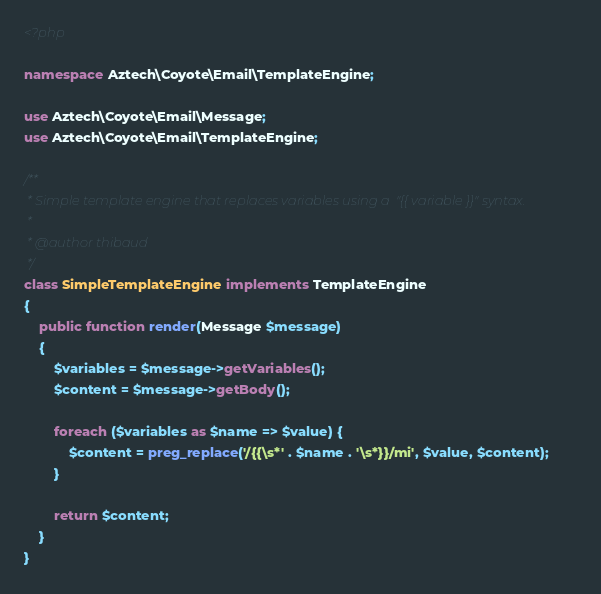Convert code to text. <code><loc_0><loc_0><loc_500><loc_500><_PHP_><?php

namespace Aztech\Coyote\Email\TemplateEngine;

use Aztech\Coyote\Email\Message;
use Aztech\Coyote\Email\TemplateEngine;

/**
 * Simple template engine that replaces variables using a  "{{ variable }}" syntax.
 *
 * @author thibaud
 */
class SimpleTemplateEngine implements TemplateEngine
{
    public function render(Message $message)
    {
        $variables = $message->getVariables();
        $content = $message->getBody();

        foreach ($variables as $name => $value) {
            $content = preg_replace('/{{\s*' . $name . '\s*}}/mi', $value, $content);
        }

        return $content;
    }
}
</code> 